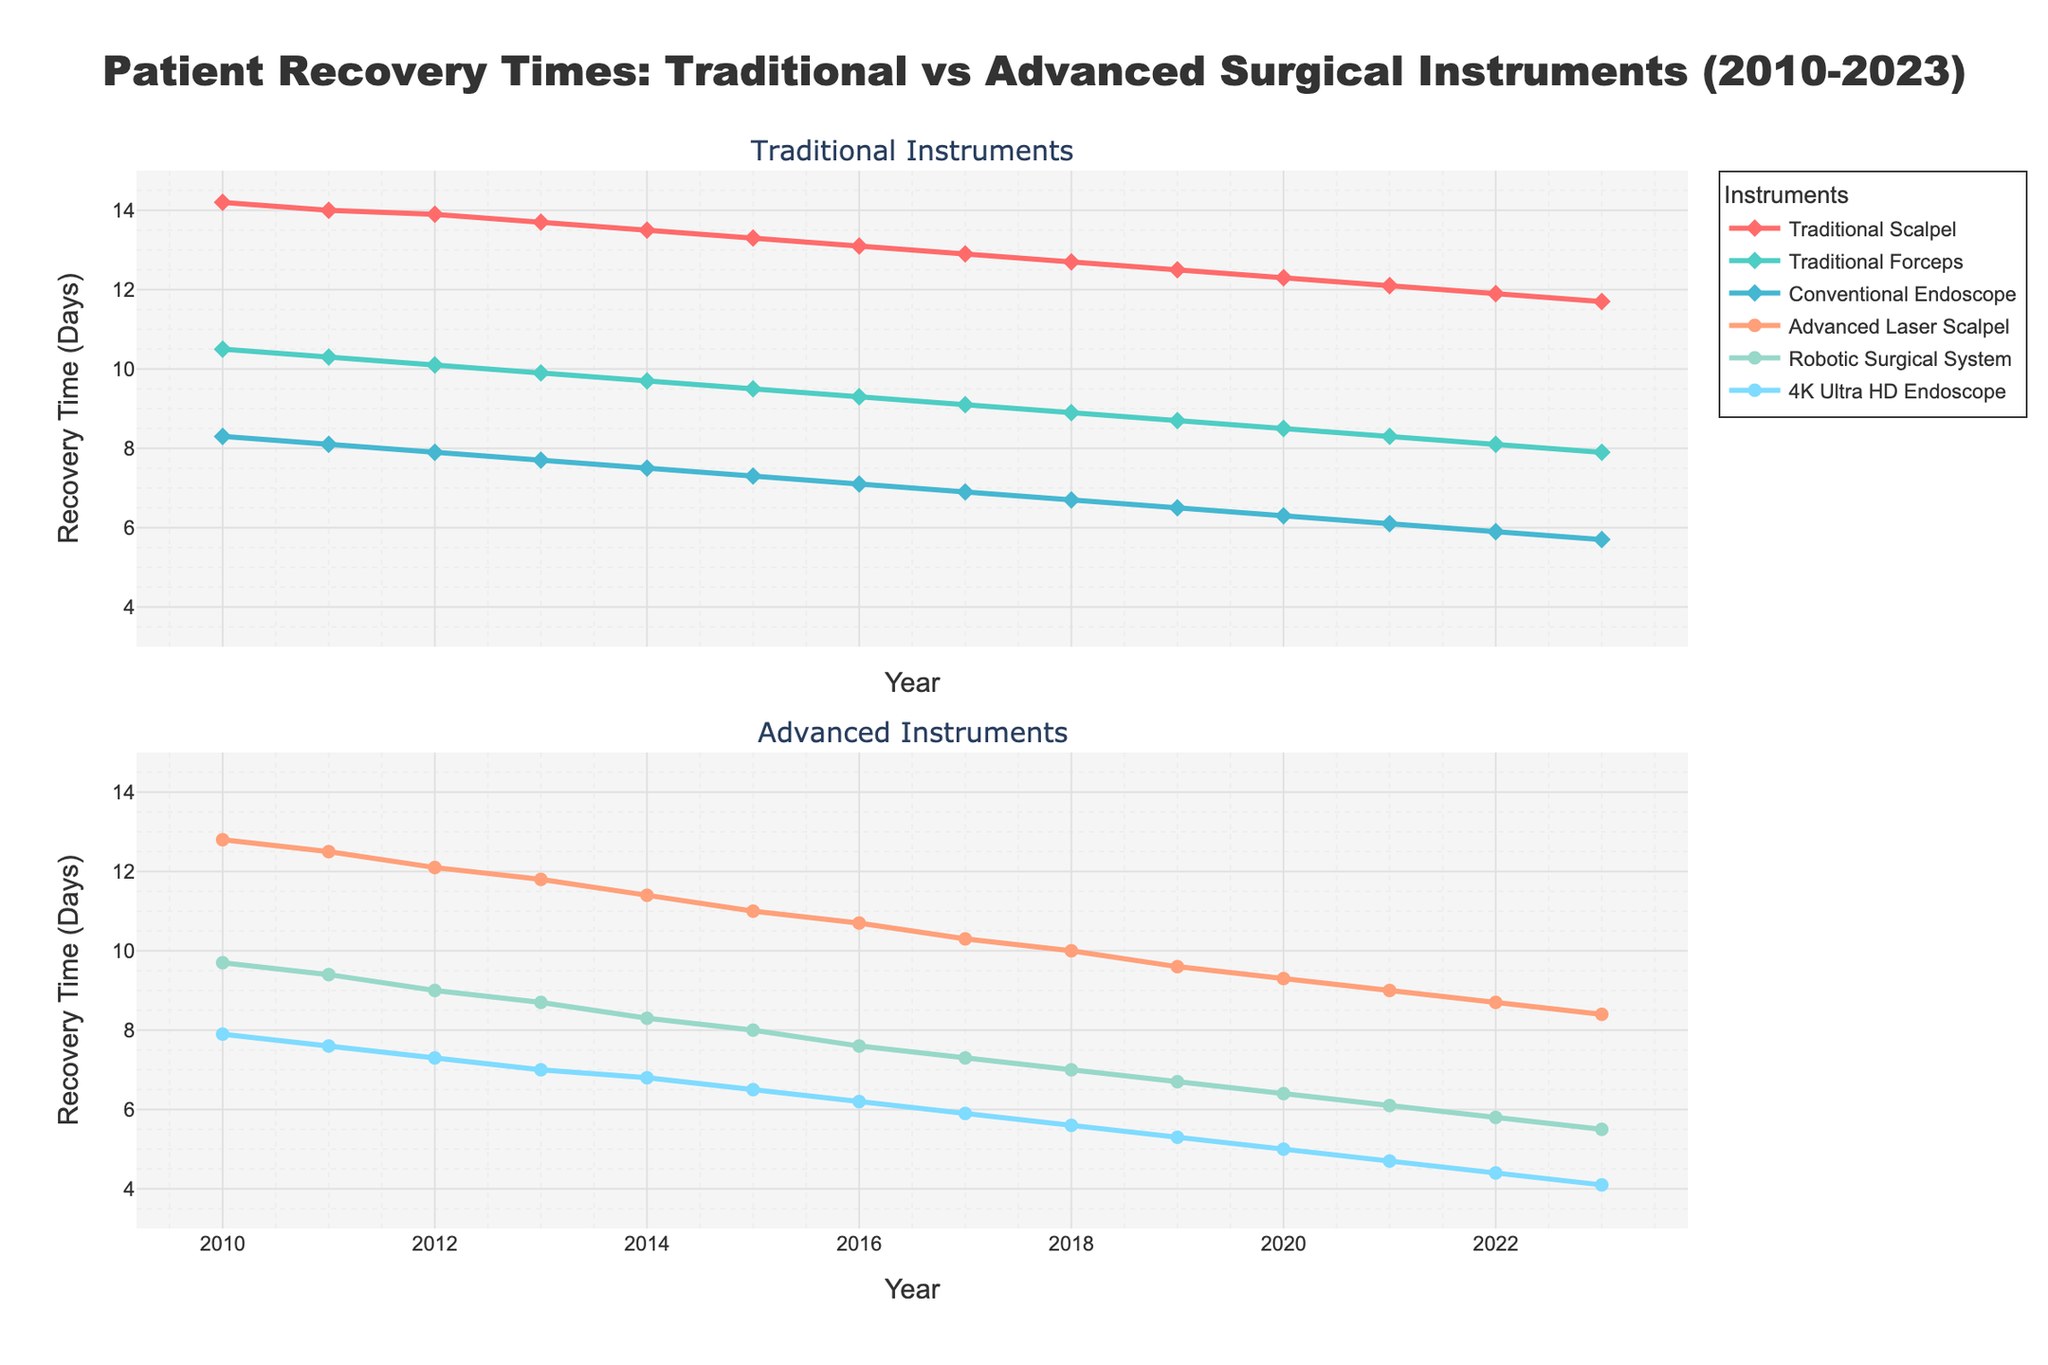How has the recovery time for procedures using the Traditional Scalpel changed from 2010 to 2023? The recovery time for the Traditional Scalpel in 2010 was 14.2 days and decreased to 11.7 days by 2023.
Answer: Decreased from 14.2 days to 11.7 days Which advanced surgical instrument had the shortest recovery time in 2023? In 2023, the 4K Ultra HD Endoscope had the shortest recovery time among the advanced instruments, with 4.1 days.
Answer: 4K Ultra HD Endoscope In which year did the recovery time for procedures using the Robotic Surgical System first drop below 7 days? By observing the trend, the recovery time for the Robotic Surgical System first dropped below 7 days in 2019.
Answer: 2019 Compare the recovery times of the Traditional Forceps and the Advanced Laser Scalpel in 2023. Which instrument had a shorter recovery time? In 2023, the recovery time for the Traditional Forceps was 7.9 days, whereas for the Advanced Laser Scalpel it was 8.4 days.
Answer: Traditional Forceps How many days did the recovery time for procedures using the Conventional Endoscope decrease from 2010 to 2023? In 2010, the recovery time for the Conventional Endoscope was 8.3 days and dropped to 5.7 days by 2023. The decrease is 8.3 - 5.7.
Answer: 2.6 days Which traditional surgical instrument exhibited the smallest improvement in recovery times from 2010 to 2023? By comparing the changes in recovery times for the Traditional Scalpel, Traditional Forceps, and Conventional Endoscope, the Traditional Forceps showed the smallest improvement. It decreased from 10.5 to 7.9 days, an improvement of 2.6 days.
Answer: Traditional Forceps What is the difference in recovery time between the Traditional Scalpel and the 4K Ultra HD Endoscope in 2023? In 2023, the recovery time for the Traditional Scalpel is 11.7 days, and for the 4K Ultra HD Endoscope, it is 4.1 days. The difference is 11.7 - 4.1.
Answer: 7.6 days Which instrument had the most significant reduction in recovery time from 2010 to 2023? By calculating the reduction for each instrument from 2010 to 2023, the 4K Ultra HD Endoscope had the most significant reduction, declining from 7.9 to 4.1 days, a decrease of 3.8 days.
Answer: 4K Ultra HD Endoscope In what year were the recovery times for the Advanced Laser Scalpel and the Traditional Forceps equal or closest? The recovery times for the Advanced Laser Scalpel and Traditional Forceps were closest in 2013. The Advanced Laser Scalpel had a recovery time of 11.8 days and the Traditional Forceps was at 9.9 days.
Answer: 2013 